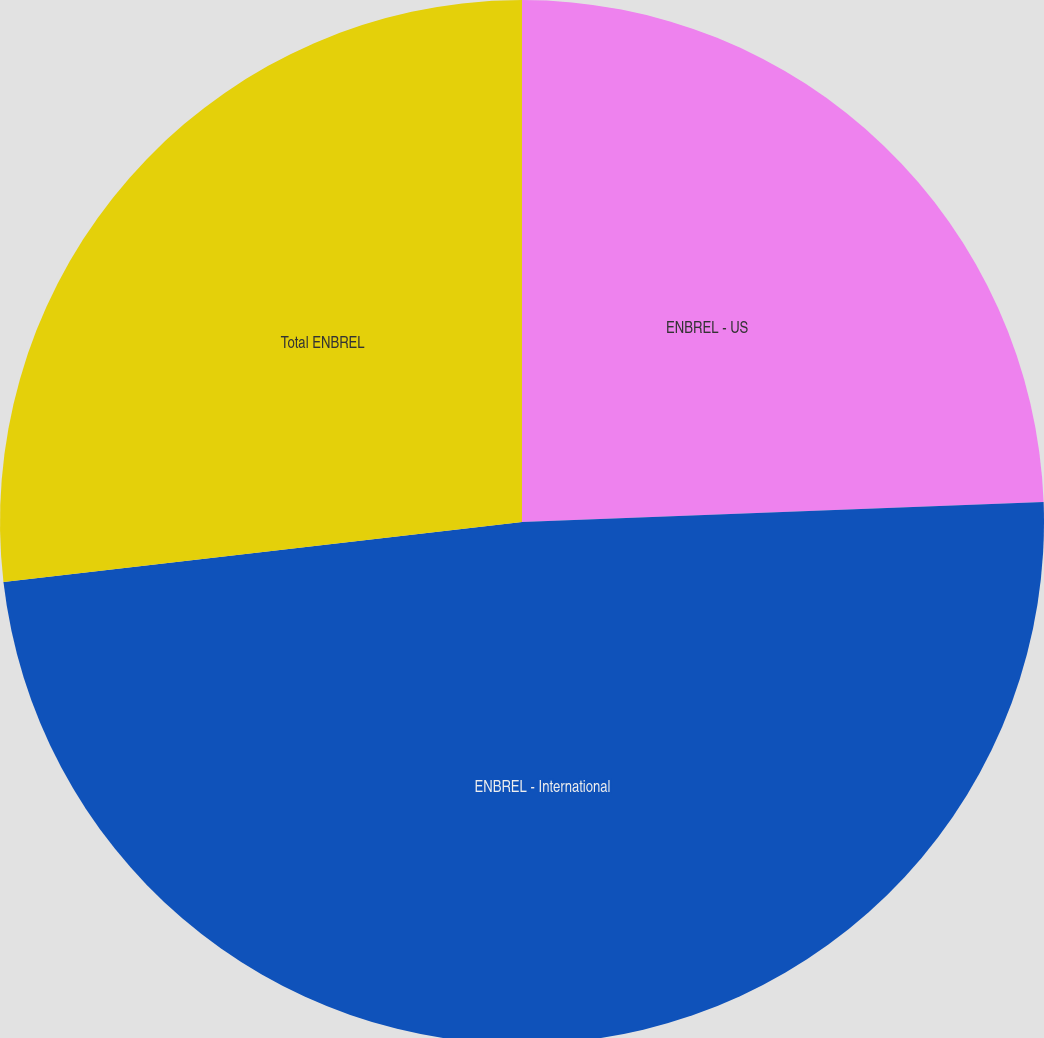Convert chart to OTSL. <chart><loc_0><loc_0><loc_500><loc_500><pie_chart><fcel>ENBREL - US<fcel>ENBREL - International<fcel>Total ENBREL<nl><fcel>24.39%<fcel>48.78%<fcel>26.83%<nl></chart> 